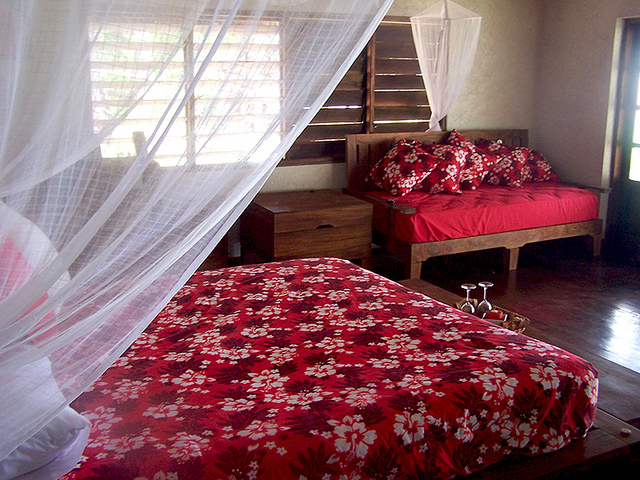Can you tell me more about the room's decor style? The room exhibits a cozy, rustic decor style, characterized by simple wooden furniture, neutral walls, and natural light filtering through the curtained window. The bright bed linens add a pop of color, complementing the earthy tones of the room. 